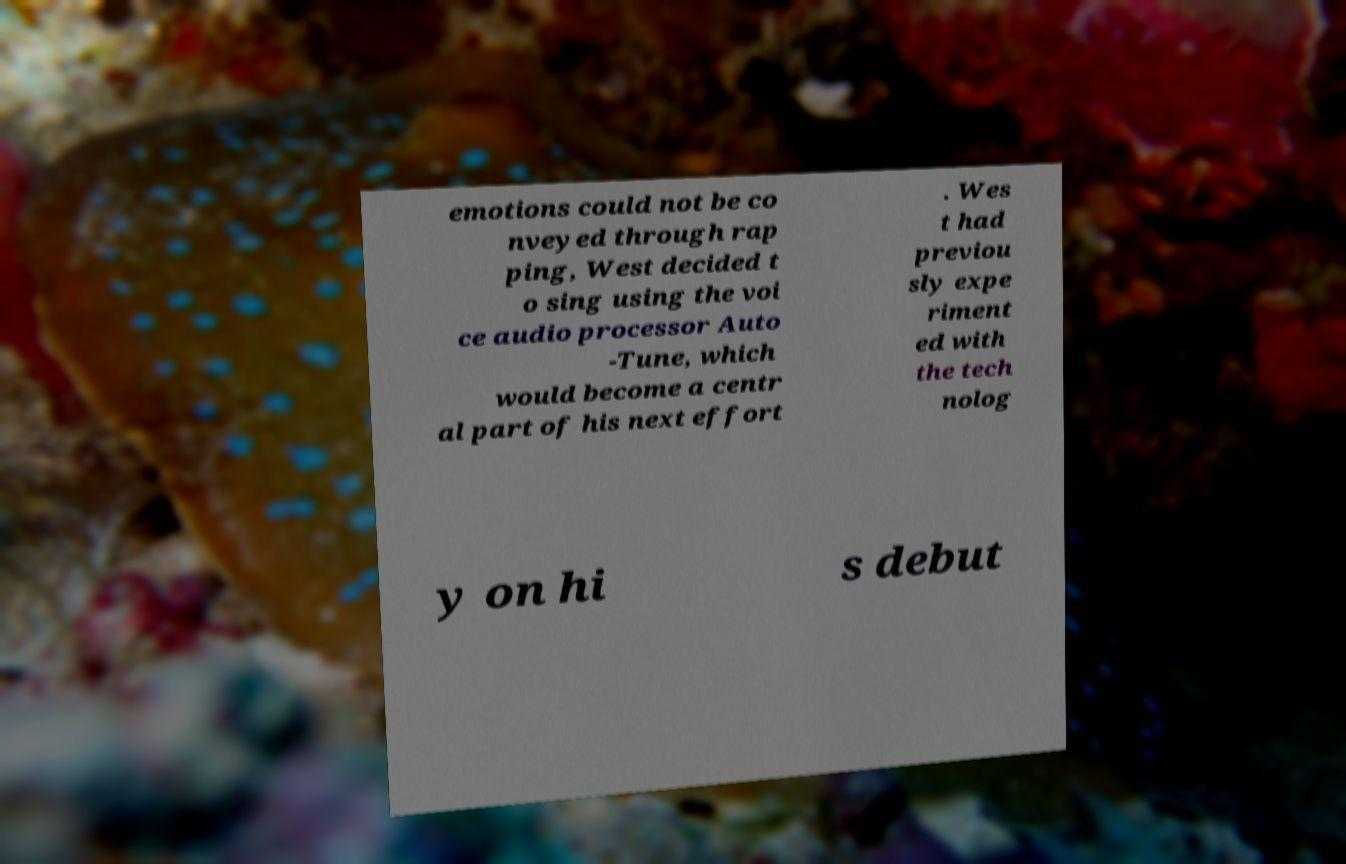Can you read and provide the text displayed in the image?This photo seems to have some interesting text. Can you extract and type it out for me? emotions could not be co nveyed through rap ping, West decided t o sing using the voi ce audio processor Auto -Tune, which would become a centr al part of his next effort . Wes t had previou sly expe riment ed with the tech nolog y on hi s debut 